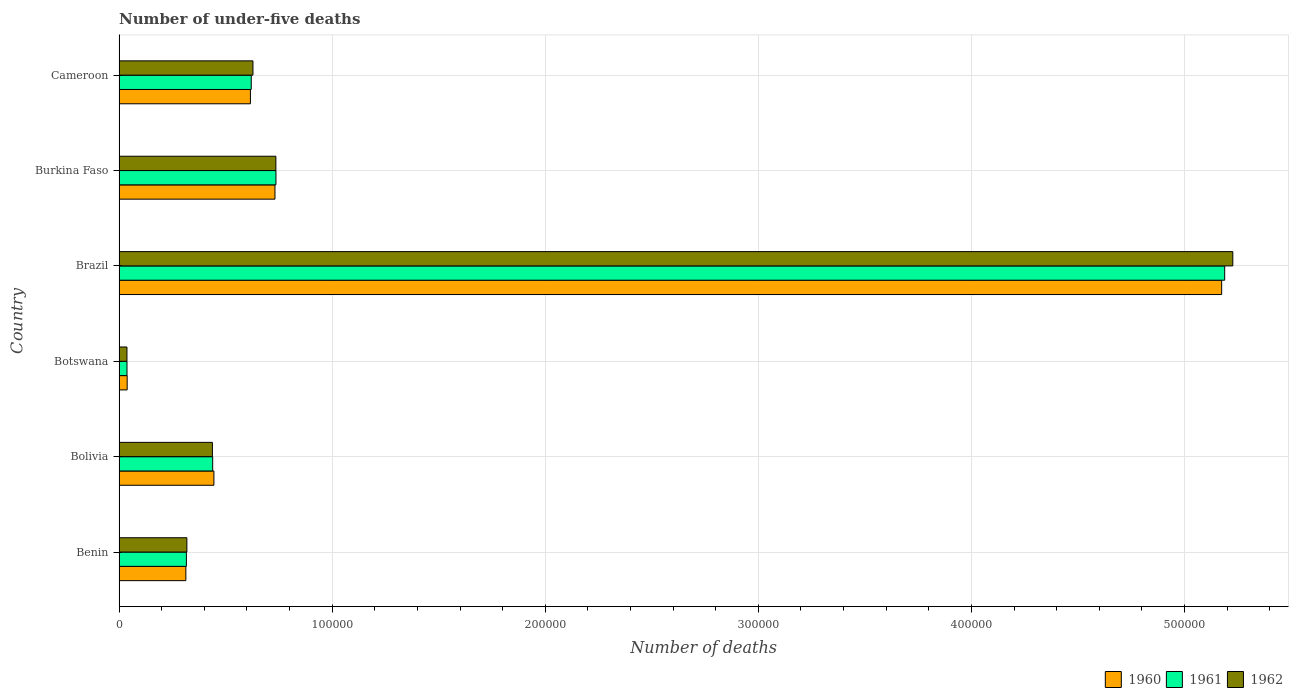How many different coloured bars are there?
Your response must be concise. 3. How many groups of bars are there?
Your response must be concise. 6. What is the label of the 2nd group of bars from the top?
Offer a terse response. Burkina Faso. What is the number of under-five deaths in 1960 in Botswana?
Make the answer very short. 3811. Across all countries, what is the maximum number of under-five deaths in 1962?
Provide a succinct answer. 5.23e+05. Across all countries, what is the minimum number of under-five deaths in 1960?
Offer a very short reply. 3811. In which country was the number of under-five deaths in 1960 minimum?
Make the answer very short. Botswana. What is the total number of under-five deaths in 1960 in the graph?
Your response must be concise. 7.32e+05. What is the difference between the number of under-five deaths in 1961 in Brazil and that in Cameroon?
Your response must be concise. 4.57e+05. What is the difference between the number of under-five deaths in 1960 in Burkina Faso and the number of under-five deaths in 1962 in Brazil?
Provide a short and direct response. -4.49e+05. What is the average number of under-five deaths in 1962 per country?
Ensure brevity in your answer.  1.23e+05. What is the difference between the number of under-five deaths in 1960 and number of under-five deaths in 1961 in Brazil?
Ensure brevity in your answer.  -1424. What is the ratio of the number of under-five deaths in 1962 in Botswana to that in Brazil?
Offer a very short reply. 0.01. Is the difference between the number of under-five deaths in 1960 in Bolivia and Brazil greater than the difference between the number of under-five deaths in 1961 in Bolivia and Brazil?
Offer a very short reply. Yes. What is the difference between the highest and the second highest number of under-five deaths in 1960?
Offer a terse response. 4.44e+05. What is the difference between the highest and the lowest number of under-five deaths in 1962?
Offer a terse response. 5.19e+05. In how many countries, is the number of under-five deaths in 1961 greater than the average number of under-five deaths in 1961 taken over all countries?
Provide a succinct answer. 1. Is it the case that in every country, the sum of the number of under-five deaths in 1962 and number of under-five deaths in 1961 is greater than the number of under-five deaths in 1960?
Keep it short and to the point. Yes. How many bars are there?
Your response must be concise. 18. How many countries are there in the graph?
Offer a very short reply. 6. Are the values on the major ticks of X-axis written in scientific E-notation?
Ensure brevity in your answer.  No. How many legend labels are there?
Keep it short and to the point. 3. What is the title of the graph?
Your answer should be compact. Number of under-five deaths. Does "2000" appear as one of the legend labels in the graph?
Provide a short and direct response. No. What is the label or title of the X-axis?
Provide a succinct answer. Number of deaths. What is the Number of deaths in 1960 in Benin?
Give a very brief answer. 3.13e+04. What is the Number of deaths in 1961 in Benin?
Ensure brevity in your answer.  3.16e+04. What is the Number of deaths of 1962 in Benin?
Ensure brevity in your answer.  3.18e+04. What is the Number of deaths in 1960 in Bolivia?
Ensure brevity in your answer.  4.45e+04. What is the Number of deaths of 1961 in Bolivia?
Give a very brief answer. 4.39e+04. What is the Number of deaths of 1962 in Bolivia?
Offer a very short reply. 4.38e+04. What is the Number of deaths of 1960 in Botswana?
Give a very brief answer. 3811. What is the Number of deaths in 1961 in Botswana?
Make the answer very short. 3727. What is the Number of deaths of 1962 in Botswana?
Offer a very short reply. 3708. What is the Number of deaths in 1960 in Brazil?
Offer a very short reply. 5.17e+05. What is the Number of deaths of 1961 in Brazil?
Keep it short and to the point. 5.19e+05. What is the Number of deaths in 1962 in Brazil?
Ensure brevity in your answer.  5.23e+05. What is the Number of deaths in 1960 in Burkina Faso?
Provide a succinct answer. 7.32e+04. What is the Number of deaths of 1961 in Burkina Faso?
Provide a short and direct response. 7.36e+04. What is the Number of deaths of 1962 in Burkina Faso?
Give a very brief answer. 7.36e+04. What is the Number of deaths in 1960 in Cameroon?
Offer a very short reply. 6.16e+04. What is the Number of deaths in 1961 in Cameroon?
Give a very brief answer. 6.20e+04. What is the Number of deaths of 1962 in Cameroon?
Give a very brief answer. 6.28e+04. Across all countries, what is the maximum Number of deaths of 1960?
Ensure brevity in your answer.  5.17e+05. Across all countries, what is the maximum Number of deaths in 1961?
Make the answer very short. 5.19e+05. Across all countries, what is the maximum Number of deaths in 1962?
Your answer should be very brief. 5.23e+05. Across all countries, what is the minimum Number of deaths of 1960?
Your answer should be very brief. 3811. Across all countries, what is the minimum Number of deaths of 1961?
Your response must be concise. 3727. Across all countries, what is the minimum Number of deaths in 1962?
Make the answer very short. 3708. What is the total Number of deaths of 1960 in the graph?
Your answer should be very brief. 7.32e+05. What is the total Number of deaths in 1961 in the graph?
Ensure brevity in your answer.  7.34e+05. What is the total Number of deaths of 1962 in the graph?
Provide a succinct answer. 7.38e+05. What is the difference between the Number of deaths of 1960 in Benin and that in Bolivia?
Offer a very short reply. -1.32e+04. What is the difference between the Number of deaths in 1961 in Benin and that in Bolivia?
Keep it short and to the point. -1.23e+04. What is the difference between the Number of deaths in 1962 in Benin and that in Bolivia?
Offer a very short reply. -1.20e+04. What is the difference between the Number of deaths in 1960 in Benin and that in Botswana?
Provide a succinct answer. 2.75e+04. What is the difference between the Number of deaths of 1961 in Benin and that in Botswana?
Ensure brevity in your answer.  2.79e+04. What is the difference between the Number of deaths of 1962 in Benin and that in Botswana?
Your answer should be very brief. 2.81e+04. What is the difference between the Number of deaths of 1960 in Benin and that in Brazil?
Your response must be concise. -4.86e+05. What is the difference between the Number of deaths of 1961 in Benin and that in Brazil?
Offer a terse response. -4.87e+05. What is the difference between the Number of deaths of 1962 in Benin and that in Brazil?
Give a very brief answer. -4.91e+05. What is the difference between the Number of deaths of 1960 in Benin and that in Burkina Faso?
Give a very brief answer. -4.18e+04. What is the difference between the Number of deaths in 1961 in Benin and that in Burkina Faso?
Provide a succinct answer. -4.20e+04. What is the difference between the Number of deaths of 1962 in Benin and that in Burkina Faso?
Your answer should be very brief. -4.18e+04. What is the difference between the Number of deaths in 1960 in Benin and that in Cameroon?
Provide a succinct answer. -3.03e+04. What is the difference between the Number of deaths of 1961 in Benin and that in Cameroon?
Provide a succinct answer. -3.04e+04. What is the difference between the Number of deaths of 1962 in Benin and that in Cameroon?
Provide a short and direct response. -3.10e+04. What is the difference between the Number of deaths of 1960 in Bolivia and that in Botswana?
Your answer should be compact. 4.07e+04. What is the difference between the Number of deaths in 1961 in Bolivia and that in Botswana?
Keep it short and to the point. 4.02e+04. What is the difference between the Number of deaths of 1962 in Bolivia and that in Botswana?
Your answer should be very brief. 4.01e+04. What is the difference between the Number of deaths in 1960 in Bolivia and that in Brazil?
Give a very brief answer. -4.73e+05. What is the difference between the Number of deaths in 1961 in Bolivia and that in Brazil?
Offer a very short reply. -4.75e+05. What is the difference between the Number of deaths in 1962 in Bolivia and that in Brazil?
Provide a short and direct response. -4.79e+05. What is the difference between the Number of deaths in 1960 in Bolivia and that in Burkina Faso?
Offer a terse response. -2.87e+04. What is the difference between the Number of deaths of 1961 in Bolivia and that in Burkina Faso?
Ensure brevity in your answer.  -2.97e+04. What is the difference between the Number of deaths in 1962 in Bolivia and that in Burkina Faso?
Give a very brief answer. -2.98e+04. What is the difference between the Number of deaths in 1960 in Bolivia and that in Cameroon?
Your answer should be compact. -1.71e+04. What is the difference between the Number of deaths of 1961 in Bolivia and that in Cameroon?
Provide a short and direct response. -1.81e+04. What is the difference between the Number of deaths of 1962 in Bolivia and that in Cameroon?
Give a very brief answer. -1.90e+04. What is the difference between the Number of deaths of 1960 in Botswana and that in Brazil?
Provide a short and direct response. -5.14e+05. What is the difference between the Number of deaths in 1961 in Botswana and that in Brazil?
Keep it short and to the point. -5.15e+05. What is the difference between the Number of deaths of 1962 in Botswana and that in Brazil?
Keep it short and to the point. -5.19e+05. What is the difference between the Number of deaths in 1960 in Botswana and that in Burkina Faso?
Provide a short and direct response. -6.94e+04. What is the difference between the Number of deaths in 1961 in Botswana and that in Burkina Faso?
Give a very brief answer. -6.99e+04. What is the difference between the Number of deaths of 1962 in Botswana and that in Burkina Faso?
Make the answer very short. -6.99e+04. What is the difference between the Number of deaths of 1960 in Botswana and that in Cameroon?
Make the answer very short. -5.78e+04. What is the difference between the Number of deaths in 1961 in Botswana and that in Cameroon?
Keep it short and to the point. -5.83e+04. What is the difference between the Number of deaths in 1962 in Botswana and that in Cameroon?
Your response must be concise. -5.91e+04. What is the difference between the Number of deaths of 1960 in Brazil and that in Burkina Faso?
Your answer should be very brief. 4.44e+05. What is the difference between the Number of deaths of 1961 in Brazil and that in Burkina Faso?
Your response must be concise. 4.45e+05. What is the difference between the Number of deaths in 1962 in Brazil and that in Burkina Faso?
Your answer should be compact. 4.49e+05. What is the difference between the Number of deaths of 1960 in Brazil and that in Cameroon?
Offer a very short reply. 4.56e+05. What is the difference between the Number of deaths in 1961 in Brazil and that in Cameroon?
Make the answer very short. 4.57e+05. What is the difference between the Number of deaths in 1962 in Brazil and that in Cameroon?
Keep it short and to the point. 4.60e+05. What is the difference between the Number of deaths in 1960 in Burkina Faso and that in Cameroon?
Ensure brevity in your answer.  1.15e+04. What is the difference between the Number of deaths in 1961 in Burkina Faso and that in Cameroon?
Keep it short and to the point. 1.16e+04. What is the difference between the Number of deaths of 1962 in Burkina Faso and that in Cameroon?
Make the answer very short. 1.08e+04. What is the difference between the Number of deaths of 1960 in Benin and the Number of deaths of 1961 in Bolivia?
Your response must be concise. -1.26e+04. What is the difference between the Number of deaths in 1960 in Benin and the Number of deaths in 1962 in Bolivia?
Make the answer very short. -1.25e+04. What is the difference between the Number of deaths in 1961 in Benin and the Number of deaths in 1962 in Bolivia?
Ensure brevity in your answer.  -1.22e+04. What is the difference between the Number of deaths in 1960 in Benin and the Number of deaths in 1961 in Botswana?
Provide a short and direct response. 2.76e+04. What is the difference between the Number of deaths in 1960 in Benin and the Number of deaths in 1962 in Botswana?
Your answer should be very brief. 2.76e+04. What is the difference between the Number of deaths in 1961 in Benin and the Number of deaths in 1962 in Botswana?
Your answer should be very brief. 2.79e+04. What is the difference between the Number of deaths of 1960 in Benin and the Number of deaths of 1961 in Brazil?
Keep it short and to the point. -4.87e+05. What is the difference between the Number of deaths of 1960 in Benin and the Number of deaths of 1962 in Brazil?
Your answer should be compact. -4.91e+05. What is the difference between the Number of deaths in 1961 in Benin and the Number of deaths in 1962 in Brazil?
Your response must be concise. -4.91e+05. What is the difference between the Number of deaths of 1960 in Benin and the Number of deaths of 1961 in Burkina Faso?
Offer a very short reply. -4.23e+04. What is the difference between the Number of deaths of 1960 in Benin and the Number of deaths of 1962 in Burkina Faso?
Make the answer very short. -4.22e+04. What is the difference between the Number of deaths of 1961 in Benin and the Number of deaths of 1962 in Burkina Faso?
Provide a short and direct response. -4.20e+04. What is the difference between the Number of deaths of 1960 in Benin and the Number of deaths of 1961 in Cameroon?
Ensure brevity in your answer.  -3.07e+04. What is the difference between the Number of deaths of 1960 in Benin and the Number of deaths of 1962 in Cameroon?
Offer a terse response. -3.15e+04. What is the difference between the Number of deaths in 1961 in Benin and the Number of deaths in 1962 in Cameroon?
Your answer should be compact. -3.12e+04. What is the difference between the Number of deaths in 1960 in Bolivia and the Number of deaths in 1961 in Botswana?
Offer a very short reply. 4.08e+04. What is the difference between the Number of deaths of 1960 in Bolivia and the Number of deaths of 1962 in Botswana?
Make the answer very short. 4.08e+04. What is the difference between the Number of deaths of 1961 in Bolivia and the Number of deaths of 1962 in Botswana?
Offer a very short reply. 4.02e+04. What is the difference between the Number of deaths in 1960 in Bolivia and the Number of deaths in 1961 in Brazil?
Ensure brevity in your answer.  -4.74e+05. What is the difference between the Number of deaths in 1960 in Bolivia and the Number of deaths in 1962 in Brazil?
Provide a short and direct response. -4.78e+05. What is the difference between the Number of deaths in 1961 in Bolivia and the Number of deaths in 1962 in Brazil?
Make the answer very short. -4.79e+05. What is the difference between the Number of deaths of 1960 in Bolivia and the Number of deaths of 1961 in Burkina Faso?
Provide a short and direct response. -2.91e+04. What is the difference between the Number of deaths of 1960 in Bolivia and the Number of deaths of 1962 in Burkina Faso?
Ensure brevity in your answer.  -2.91e+04. What is the difference between the Number of deaths in 1961 in Bolivia and the Number of deaths in 1962 in Burkina Faso?
Offer a very short reply. -2.96e+04. What is the difference between the Number of deaths of 1960 in Bolivia and the Number of deaths of 1961 in Cameroon?
Keep it short and to the point. -1.75e+04. What is the difference between the Number of deaths of 1960 in Bolivia and the Number of deaths of 1962 in Cameroon?
Keep it short and to the point. -1.83e+04. What is the difference between the Number of deaths in 1961 in Bolivia and the Number of deaths in 1962 in Cameroon?
Keep it short and to the point. -1.89e+04. What is the difference between the Number of deaths of 1960 in Botswana and the Number of deaths of 1961 in Brazil?
Keep it short and to the point. -5.15e+05. What is the difference between the Number of deaths in 1960 in Botswana and the Number of deaths in 1962 in Brazil?
Your answer should be very brief. -5.19e+05. What is the difference between the Number of deaths of 1961 in Botswana and the Number of deaths of 1962 in Brazil?
Your answer should be very brief. -5.19e+05. What is the difference between the Number of deaths of 1960 in Botswana and the Number of deaths of 1961 in Burkina Faso?
Offer a very short reply. -6.98e+04. What is the difference between the Number of deaths in 1960 in Botswana and the Number of deaths in 1962 in Burkina Faso?
Your response must be concise. -6.98e+04. What is the difference between the Number of deaths in 1961 in Botswana and the Number of deaths in 1962 in Burkina Faso?
Ensure brevity in your answer.  -6.99e+04. What is the difference between the Number of deaths of 1960 in Botswana and the Number of deaths of 1961 in Cameroon?
Provide a succinct answer. -5.82e+04. What is the difference between the Number of deaths of 1960 in Botswana and the Number of deaths of 1962 in Cameroon?
Offer a terse response. -5.90e+04. What is the difference between the Number of deaths of 1961 in Botswana and the Number of deaths of 1962 in Cameroon?
Your answer should be compact. -5.91e+04. What is the difference between the Number of deaths in 1960 in Brazil and the Number of deaths in 1961 in Burkina Faso?
Keep it short and to the point. 4.44e+05. What is the difference between the Number of deaths in 1960 in Brazil and the Number of deaths in 1962 in Burkina Faso?
Make the answer very short. 4.44e+05. What is the difference between the Number of deaths of 1961 in Brazil and the Number of deaths of 1962 in Burkina Faso?
Ensure brevity in your answer.  4.45e+05. What is the difference between the Number of deaths of 1960 in Brazil and the Number of deaths of 1961 in Cameroon?
Offer a terse response. 4.55e+05. What is the difference between the Number of deaths of 1960 in Brazil and the Number of deaths of 1962 in Cameroon?
Your answer should be compact. 4.55e+05. What is the difference between the Number of deaths of 1961 in Brazil and the Number of deaths of 1962 in Cameroon?
Keep it short and to the point. 4.56e+05. What is the difference between the Number of deaths of 1960 in Burkina Faso and the Number of deaths of 1961 in Cameroon?
Your answer should be very brief. 1.11e+04. What is the difference between the Number of deaths in 1960 in Burkina Faso and the Number of deaths in 1962 in Cameroon?
Give a very brief answer. 1.03e+04. What is the difference between the Number of deaths in 1961 in Burkina Faso and the Number of deaths in 1962 in Cameroon?
Provide a succinct answer. 1.08e+04. What is the average Number of deaths of 1960 per country?
Your answer should be very brief. 1.22e+05. What is the average Number of deaths in 1961 per country?
Give a very brief answer. 1.22e+05. What is the average Number of deaths of 1962 per country?
Offer a terse response. 1.23e+05. What is the difference between the Number of deaths in 1960 and Number of deaths in 1961 in Benin?
Provide a short and direct response. -252. What is the difference between the Number of deaths in 1960 and Number of deaths in 1962 in Benin?
Give a very brief answer. -477. What is the difference between the Number of deaths in 1961 and Number of deaths in 1962 in Benin?
Give a very brief answer. -225. What is the difference between the Number of deaths of 1960 and Number of deaths of 1961 in Bolivia?
Keep it short and to the point. 571. What is the difference between the Number of deaths of 1960 and Number of deaths of 1962 in Bolivia?
Offer a very short reply. 704. What is the difference between the Number of deaths of 1961 and Number of deaths of 1962 in Bolivia?
Your answer should be compact. 133. What is the difference between the Number of deaths in 1960 and Number of deaths in 1962 in Botswana?
Ensure brevity in your answer.  103. What is the difference between the Number of deaths in 1961 and Number of deaths in 1962 in Botswana?
Provide a succinct answer. 19. What is the difference between the Number of deaths of 1960 and Number of deaths of 1961 in Brazil?
Offer a terse response. -1424. What is the difference between the Number of deaths in 1960 and Number of deaths in 1962 in Brazil?
Ensure brevity in your answer.  -5233. What is the difference between the Number of deaths in 1961 and Number of deaths in 1962 in Brazil?
Keep it short and to the point. -3809. What is the difference between the Number of deaths of 1960 and Number of deaths of 1961 in Burkina Faso?
Your answer should be very brief. -465. What is the difference between the Number of deaths of 1960 and Number of deaths of 1962 in Burkina Faso?
Keep it short and to the point. -423. What is the difference between the Number of deaths of 1960 and Number of deaths of 1961 in Cameroon?
Your answer should be very brief. -396. What is the difference between the Number of deaths in 1960 and Number of deaths in 1962 in Cameroon?
Your answer should be compact. -1194. What is the difference between the Number of deaths in 1961 and Number of deaths in 1962 in Cameroon?
Provide a succinct answer. -798. What is the ratio of the Number of deaths in 1960 in Benin to that in Bolivia?
Ensure brevity in your answer.  0.7. What is the ratio of the Number of deaths of 1961 in Benin to that in Bolivia?
Your response must be concise. 0.72. What is the ratio of the Number of deaths of 1962 in Benin to that in Bolivia?
Keep it short and to the point. 0.73. What is the ratio of the Number of deaths in 1960 in Benin to that in Botswana?
Ensure brevity in your answer.  8.23. What is the ratio of the Number of deaths in 1961 in Benin to that in Botswana?
Your answer should be very brief. 8.48. What is the ratio of the Number of deaths in 1962 in Benin to that in Botswana?
Your answer should be compact. 8.58. What is the ratio of the Number of deaths in 1960 in Benin to that in Brazil?
Ensure brevity in your answer.  0.06. What is the ratio of the Number of deaths in 1961 in Benin to that in Brazil?
Offer a very short reply. 0.06. What is the ratio of the Number of deaths of 1962 in Benin to that in Brazil?
Your answer should be very brief. 0.06. What is the ratio of the Number of deaths of 1960 in Benin to that in Burkina Faso?
Offer a terse response. 0.43. What is the ratio of the Number of deaths of 1961 in Benin to that in Burkina Faso?
Give a very brief answer. 0.43. What is the ratio of the Number of deaths in 1962 in Benin to that in Burkina Faso?
Ensure brevity in your answer.  0.43. What is the ratio of the Number of deaths in 1960 in Benin to that in Cameroon?
Your response must be concise. 0.51. What is the ratio of the Number of deaths in 1961 in Benin to that in Cameroon?
Make the answer very short. 0.51. What is the ratio of the Number of deaths of 1962 in Benin to that in Cameroon?
Your response must be concise. 0.51. What is the ratio of the Number of deaths of 1960 in Bolivia to that in Botswana?
Offer a very short reply. 11.68. What is the ratio of the Number of deaths of 1961 in Bolivia to that in Botswana?
Provide a succinct answer. 11.79. What is the ratio of the Number of deaths of 1962 in Bolivia to that in Botswana?
Keep it short and to the point. 11.81. What is the ratio of the Number of deaths in 1960 in Bolivia to that in Brazil?
Give a very brief answer. 0.09. What is the ratio of the Number of deaths of 1961 in Bolivia to that in Brazil?
Keep it short and to the point. 0.08. What is the ratio of the Number of deaths in 1962 in Bolivia to that in Brazil?
Your response must be concise. 0.08. What is the ratio of the Number of deaths in 1960 in Bolivia to that in Burkina Faso?
Offer a very short reply. 0.61. What is the ratio of the Number of deaths of 1961 in Bolivia to that in Burkina Faso?
Your answer should be compact. 0.6. What is the ratio of the Number of deaths of 1962 in Bolivia to that in Burkina Faso?
Give a very brief answer. 0.6. What is the ratio of the Number of deaths of 1960 in Bolivia to that in Cameroon?
Your answer should be very brief. 0.72. What is the ratio of the Number of deaths of 1961 in Bolivia to that in Cameroon?
Offer a terse response. 0.71. What is the ratio of the Number of deaths in 1962 in Bolivia to that in Cameroon?
Your answer should be very brief. 0.7. What is the ratio of the Number of deaths of 1960 in Botswana to that in Brazil?
Offer a terse response. 0.01. What is the ratio of the Number of deaths of 1961 in Botswana to that in Brazil?
Give a very brief answer. 0.01. What is the ratio of the Number of deaths in 1962 in Botswana to that in Brazil?
Ensure brevity in your answer.  0.01. What is the ratio of the Number of deaths of 1960 in Botswana to that in Burkina Faso?
Provide a short and direct response. 0.05. What is the ratio of the Number of deaths in 1961 in Botswana to that in Burkina Faso?
Your answer should be very brief. 0.05. What is the ratio of the Number of deaths in 1962 in Botswana to that in Burkina Faso?
Make the answer very short. 0.05. What is the ratio of the Number of deaths in 1960 in Botswana to that in Cameroon?
Keep it short and to the point. 0.06. What is the ratio of the Number of deaths of 1961 in Botswana to that in Cameroon?
Provide a short and direct response. 0.06. What is the ratio of the Number of deaths of 1962 in Botswana to that in Cameroon?
Make the answer very short. 0.06. What is the ratio of the Number of deaths of 1960 in Brazil to that in Burkina Faso?
Provide a succinct answer. 7.07. What is the ratio of the Number of deaths in 1961 in Brazil to that in Burkina Faso?
Provide a succinct answer. 7.05. What is the ratio of the Number of deaths of 1962 in Brazil to that in Burkina Faso?
Your answer should be very brief. 7.1. What is the ratio of the Number of deaths of 1960 in Brazil to that in Cameroon?
Ensure brevity in your answer.  8.39. What is the ratio of the Number of deaths in 1961 in Brazil to that in Cameroon?
Your answer should be compact. 8.36. What is the ratio of the Number of deaths of 1962 in Brazil to that in Cameroon?
Ensure brevity in your answer.  8.32. What is the ratio of the Number of deaths in 1960 in Burkina Faso to that in Cameroon?
Give a very brief answer. 1.19. What is the ratio of the Number of deaths in 1961 in Burkina Faso to that in Cameroon?
Offer a very short reply. 1.19. What is the ratio of the Number of deaths of 1962 in Burkina Faso to that in Cameroon?
Offer a very short reply. 1.17. What is the difference between the highest and the second highest Number of deaths in 1960?
Your answer should be very brief. 4.44e+05. What is the difference between the highest and the second highest Number of deaths in 1961?
Your answer should be compact. 4.45e+05. What is the difference between the highest and the second highest Number of deaths of 1962?
Make the answer very short. 4.49e+05. What is the difference between the highest and the lowest Number of deaths of 1960?
Your answer should be compact. 5.14e+05. What is the difference between the highest and the lowest Number of deaths of 1961?
Offer a very short reply. 5.15e+05. What is the difference between the highest and the lowest Number of deaths in 1962?
Your response must be concise. 5.19e+05. 